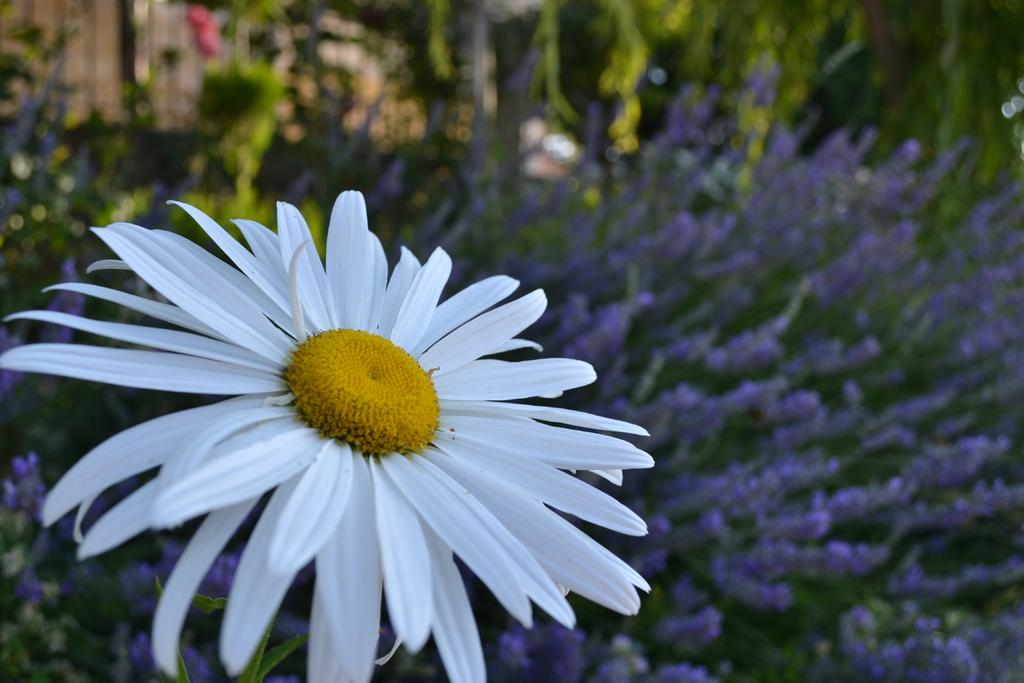What is the main subject in the foreground of the image? There is a white flower in the foreground of the image. What can be seen in the background of the image? There are flowers and plants in the background of the image. What type of substance is being used to enforce a rule in the image? There is no substance or rule enforcement present in the image; it features flowers and plants. 